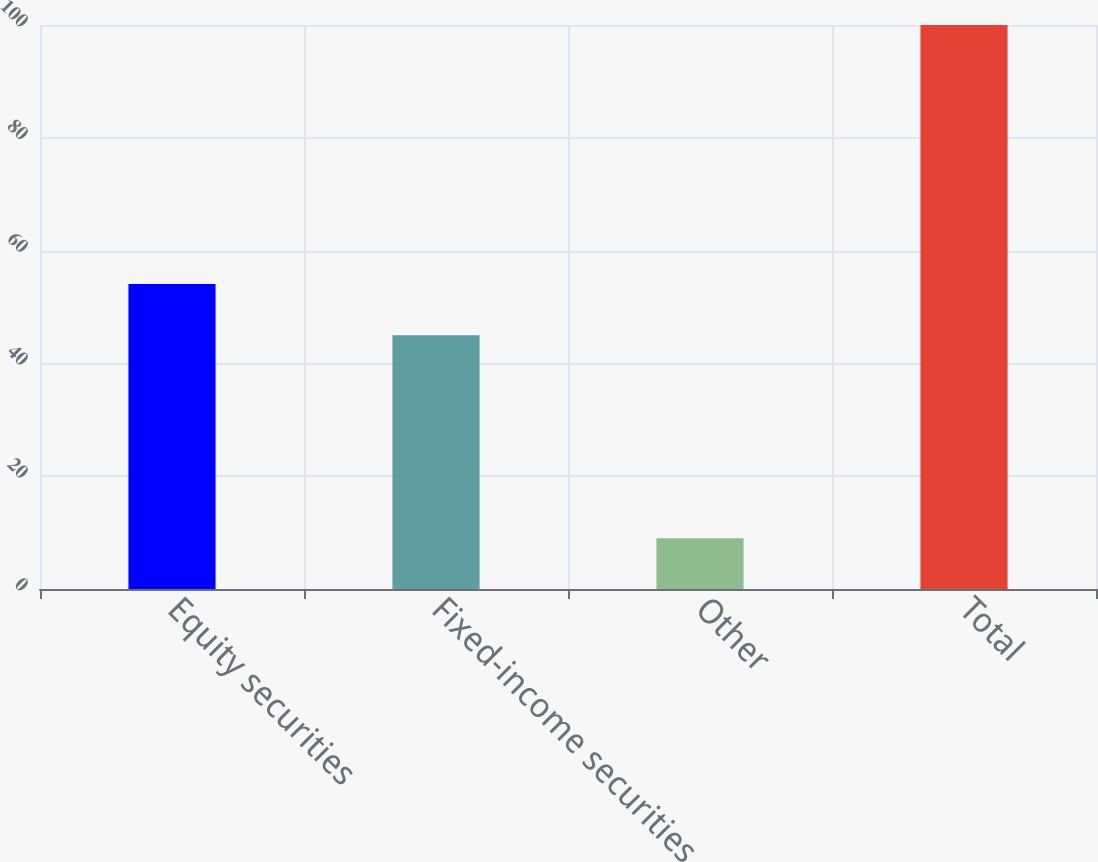Convert chart. <chart><loc_0><loc_0><loc_500><loc_500><bar_chart><fcel>Equity securities<fcel>Fixed-income securities<fcel>Other<fcel>Total<nl><fcel>54.1<fcel>45<fcel>9<fcel>100<nl></chart> 